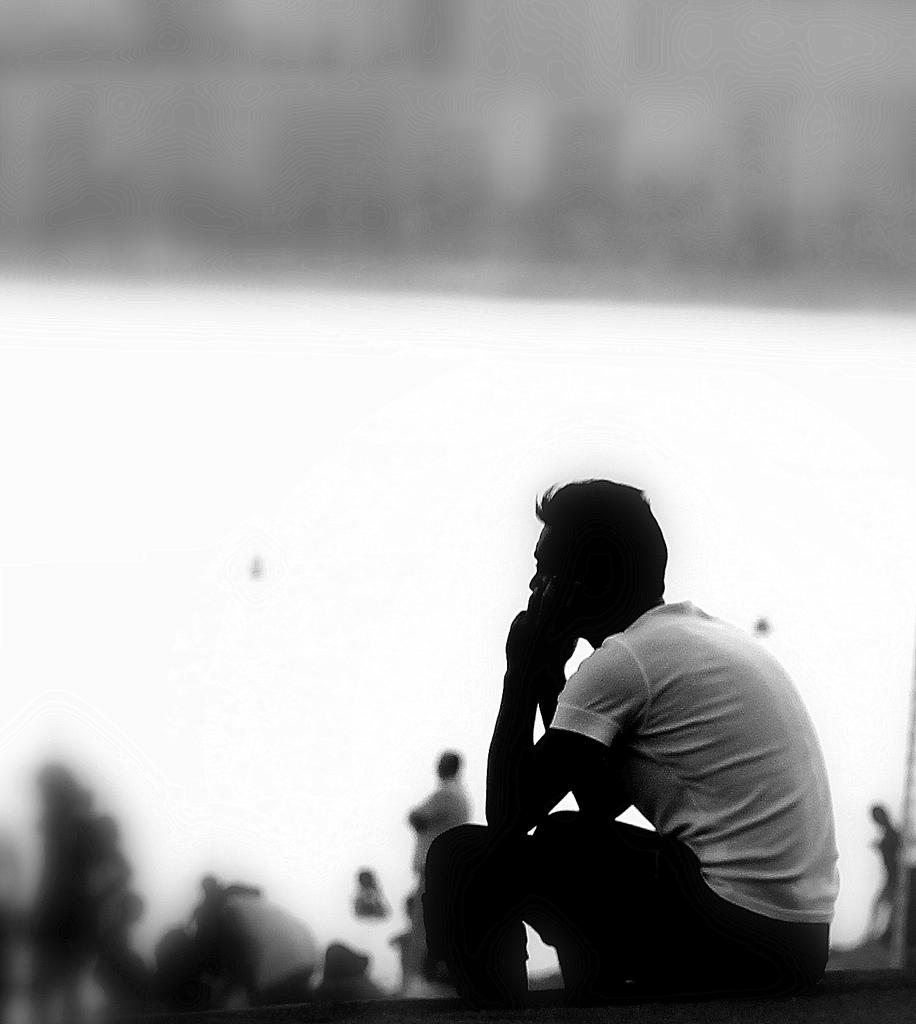What is the color scheme of the image? The image is black and white. What is the person in the image doing? The person is sitting on a platform. How would you describe the background of the image? The background of the image is blurred. Can you tell how many people are in the image? Yes, there are people visible in the image. What type of bath can be seen in the image? There is no bath present in the image. Can you describe the wren's nest in the image? There is no wren or nest visible in the image. 